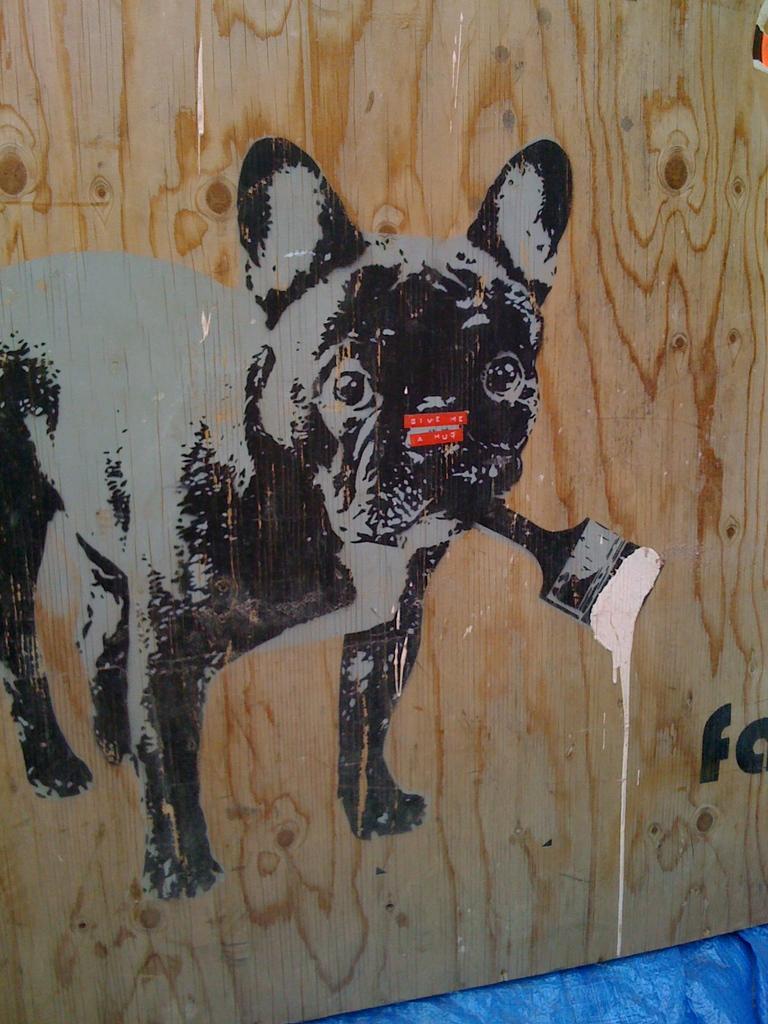Can you describe this image briefly? In this image, we can see an art on the wooden sheet contains a dog holding a brush. 